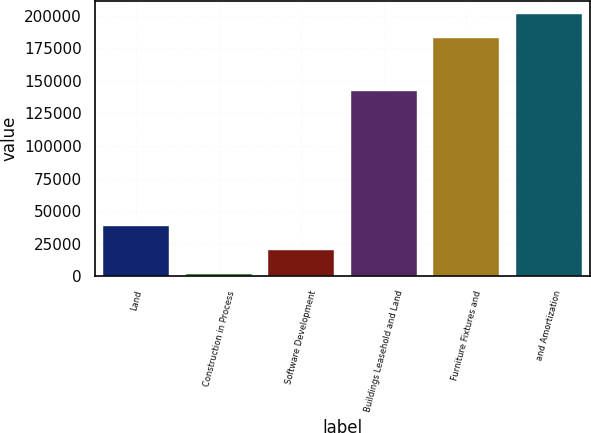Convert chart. <chart><loc_0><loc_0><loc_500><loc_500><bar_chart><fcel>Land<fcel>Construction in Process<fcel>Software Development<fcel>Buildings Leasehold and Land<fcel>Furniture Fixtures and<fcel>and Amortization<nl><fcel>38507.8<fcel>1621<fcel>20064.4<fcel>142329<fcel>182851<fcel>201294<nl></chart> 